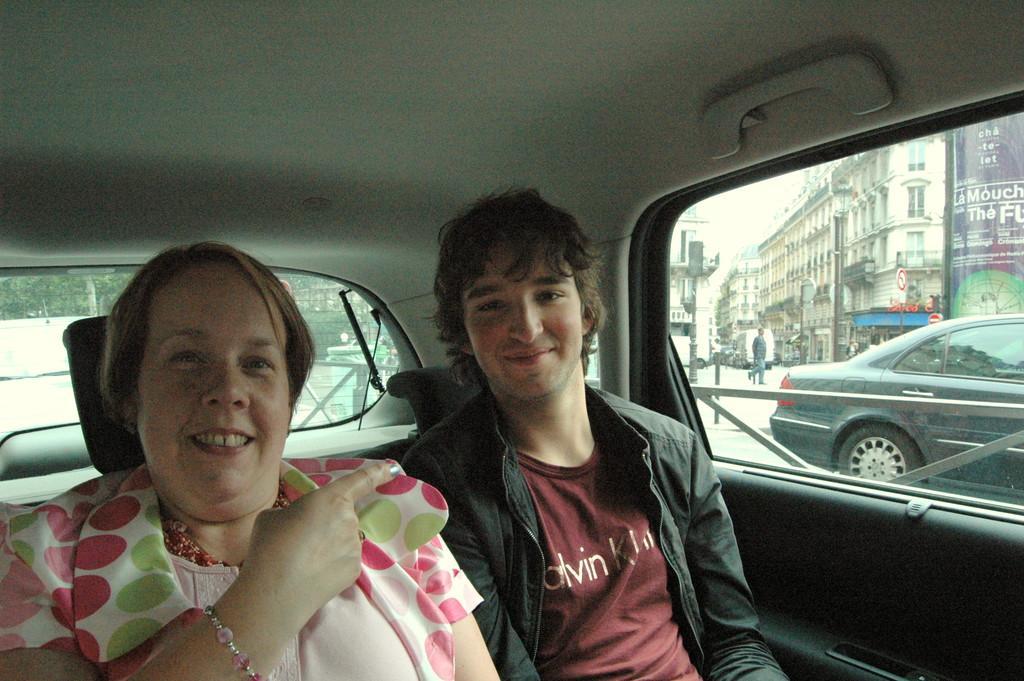Can you describe this image briefly? In the image we can see there are two people who are sitting in the car. 